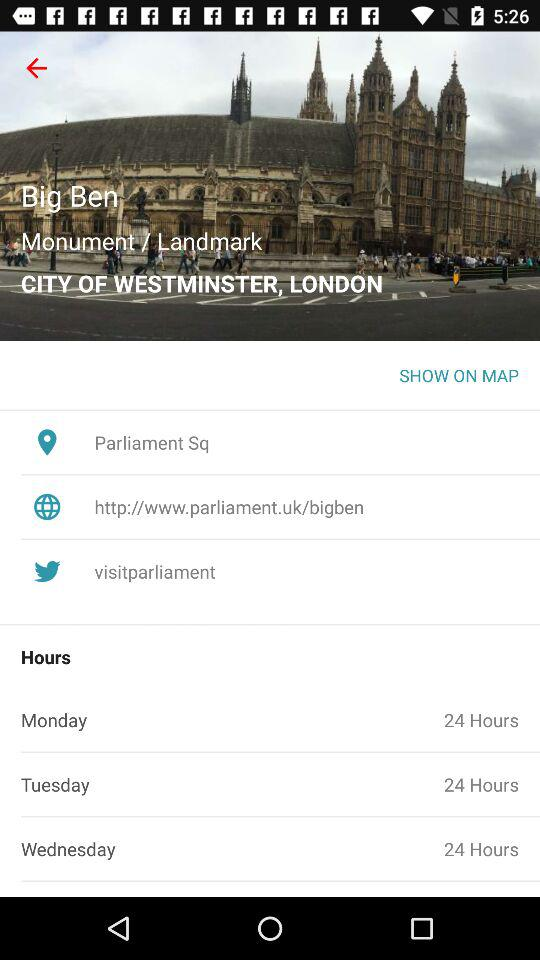What is the given location? The given location is Parliament Square. 